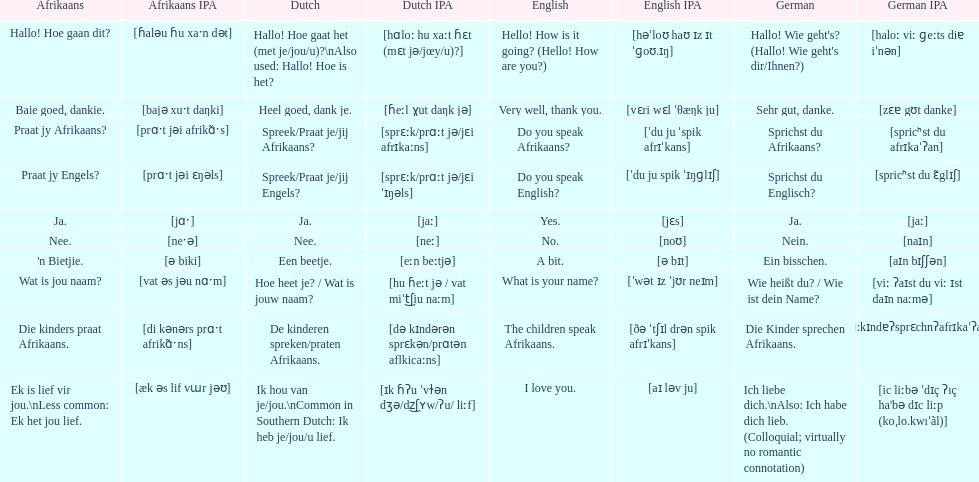Translate the following into english: 'n bietjie. A bit. 